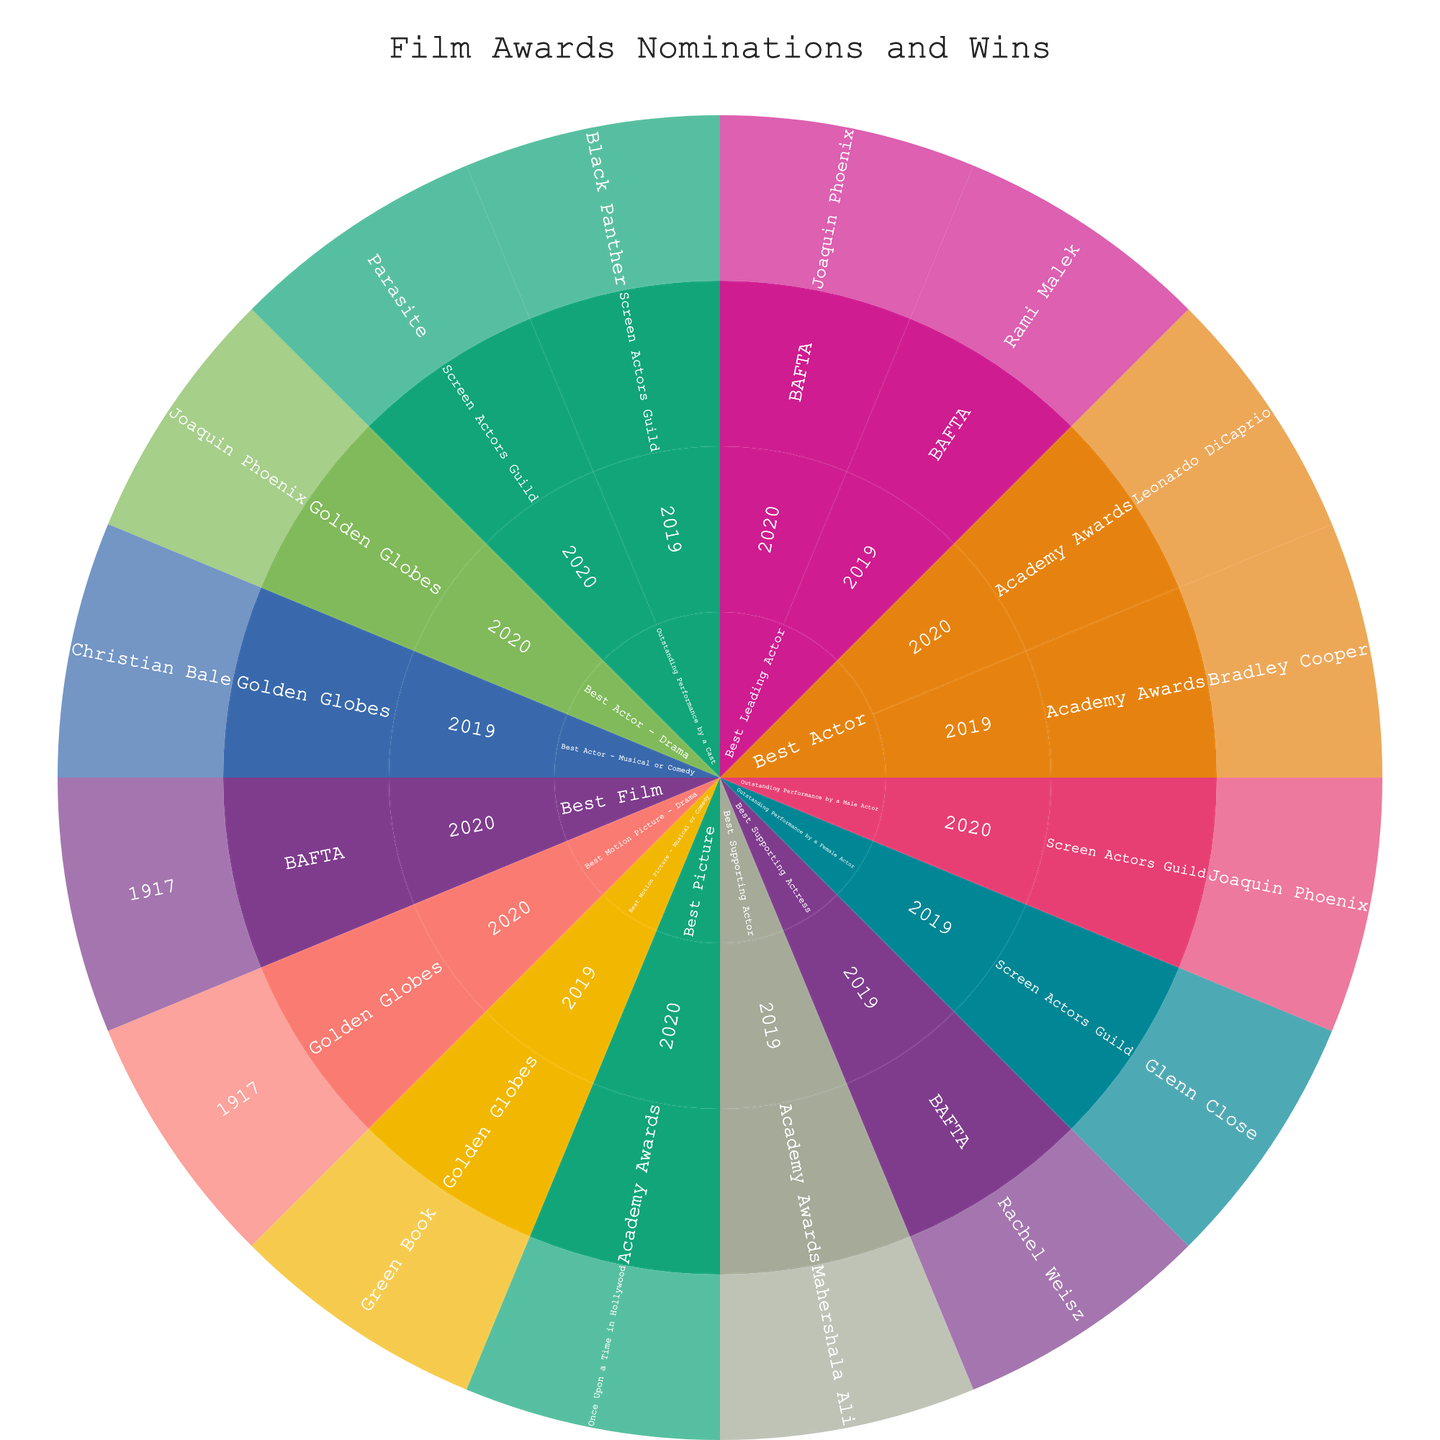what is the title of the figure? The title is usually displayed at the top of the figure. Here, it is clearly mentioned in the code.
Answer: Film Awards Nominations and Wins What are the distinct award types shown in the plot? The different award types are labeled as the outermost segments of the sunburst plot. By referring to the distinct labels in the data, we can identify them.
Answer: Academy Awards, Golden Globes, BAFTA, Screen Actors Guild Who was nominated for Best Actor in the Academy Awards in 2020? In the 'Academy Awards' segment for the year 2020, look for the 'Best Actor' category and see the nominee listed.
Answer: Leonardo DiCaprio How many categories are listed for the Academy Awards in 2019? In the 'Academy Awards' segment for the year 2019, count the number of distinct categories under this segment to find the total.
Answer: 2 Compare the nominees for Best Leading Actor in the BAFTA awards for the years 2019 and 2020. Check the 'BAFTA' segment, then navigate to the years 2019 and 2020, and within each year, look for the 'Best Leading Actor' category to identify the nominees.
Answer: Rami Malek (2019), Joaquin Phoenix (2020) Which film won the Outstanding Performance by a Cast at the Screen Actors Guild Awards in 2020? Move to the 'Screen Actors Guild' segment, then to the year 2020, and within that year, find the 'Outstanding Performance by a Cast' category to see the winning film.
Answer: Parasite How many nominations did Joaquin Phoenix receive in 2020 across all awards? Locate the year 2020 in the plot and then search each award segment for categories that list Joaquin Phoenix as the nominee. Count the total instances.
Answer: 3 Which year had more nominations for Bradley Cooper, 2019 or 2020? Identify the segments for Bradley Cooper under each year and count the number of nominations for both 2019 and 2020 to compare.
Answer: 2019 What award type and category did the movie '1917' win in 2020? Look within the 2020 segment under all award types, and find '1917'. Identify the award type and category associated with this movie.
Answer: Golden Globes: Best Motion Picture - Drama, BAFTA: Best Film Compare the number of nominations for Best Actor across all award types in the years 2019 and 2020. Tally the number of segments across all award types that list the 'Best Actor' category for each year 2019 and 2020 and compare their counts.
Answer: The number of nominations for Best Actor in 2019: 3, in 2020: 4 